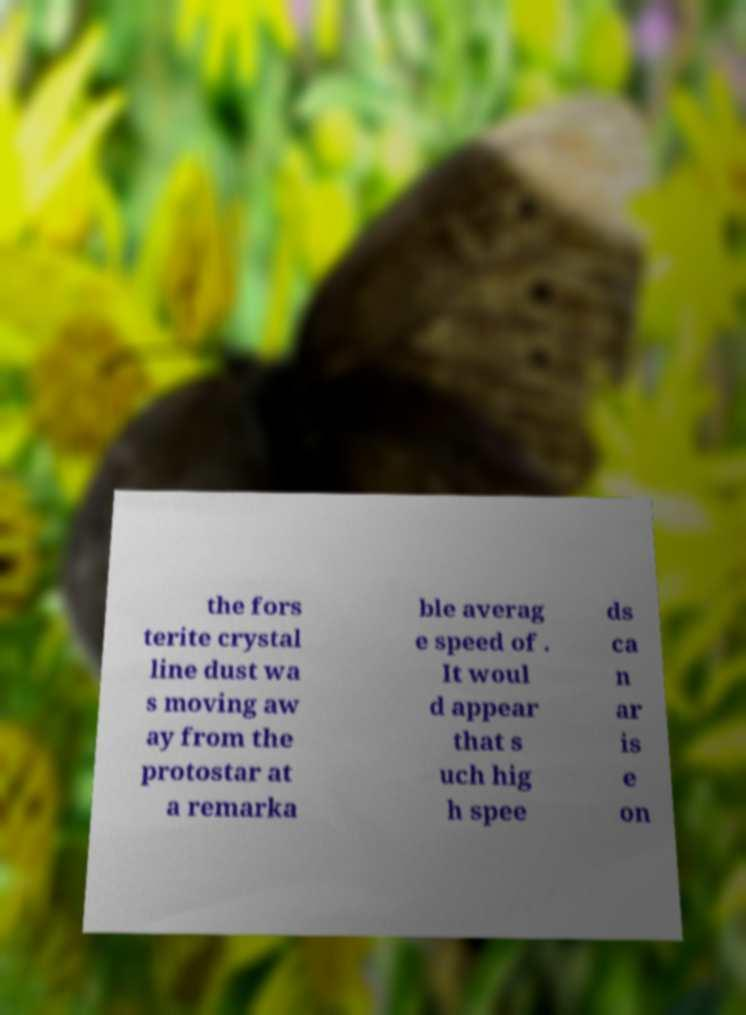For documentation purposes, I need the text within this image transcribed. Could you provide that? the fors terite crystal line dust wa s moving aw ay from the protostar at a remarka ble averag e speed of . It woul d appear that s uch hig h spee ds ca n ar is e on 